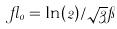<formula> <loc_0><loc_0><loc_500><loc_500>\gamma _ { 0 } = \ln ( 2 ) / \sqrt { 3 } \pi</formula> 